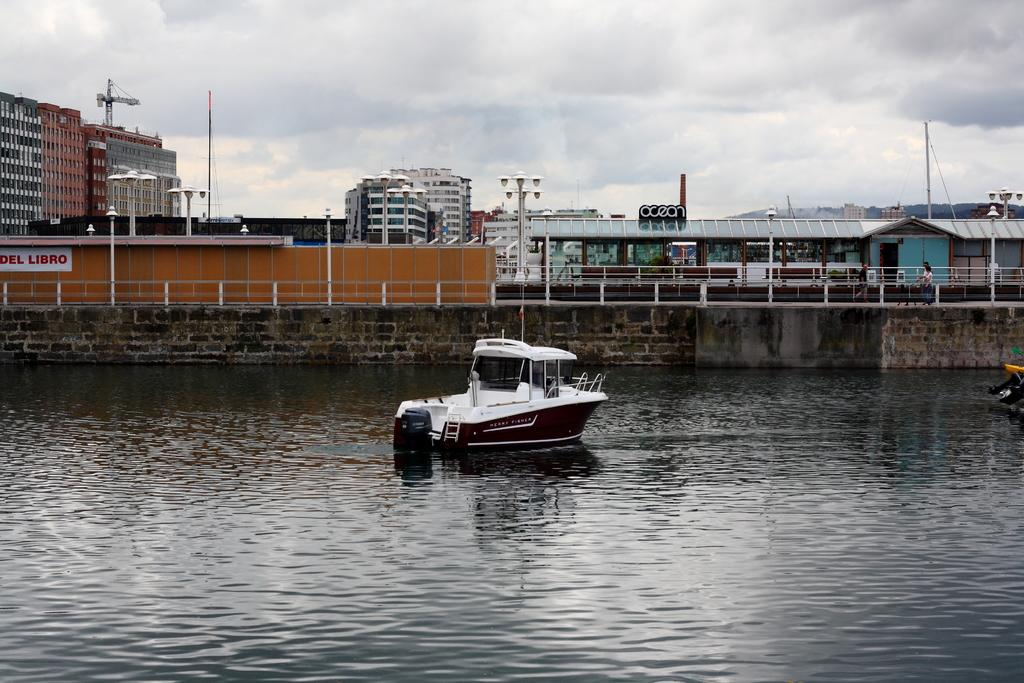<image>
Share a concise interpretation of the image provided. A small motor boat is floating near a building that says ocean. 